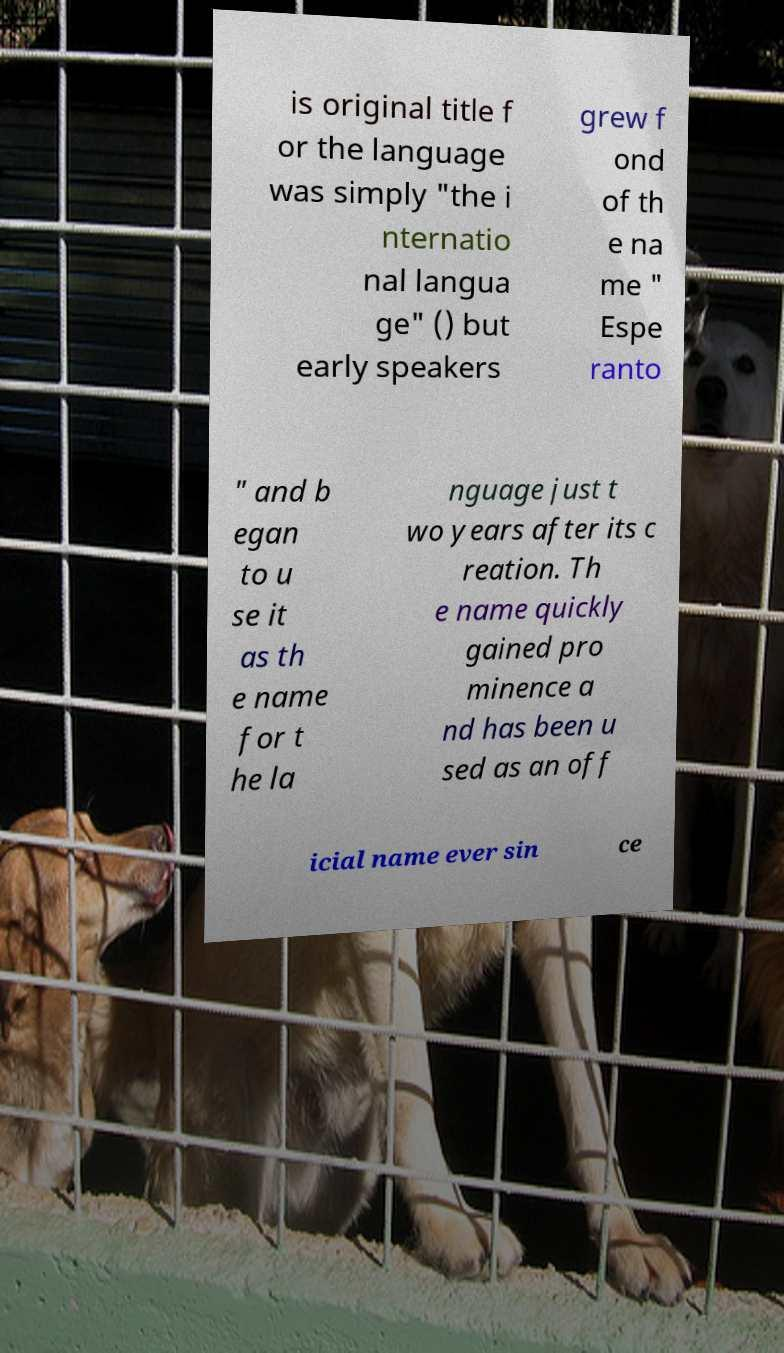Can you accurately transcribe the text from the provided image for me? is original title f or the language was simply "the i nternatio nal langua ge" () but early speakers grew f ond of th e na me " Espe ranto " and b egan to u se it as th e name for t he la nguage just t wo years after its c reation. Th e name quickly gained pro minence a nd has been u sed as an off icial name ever sin ce 